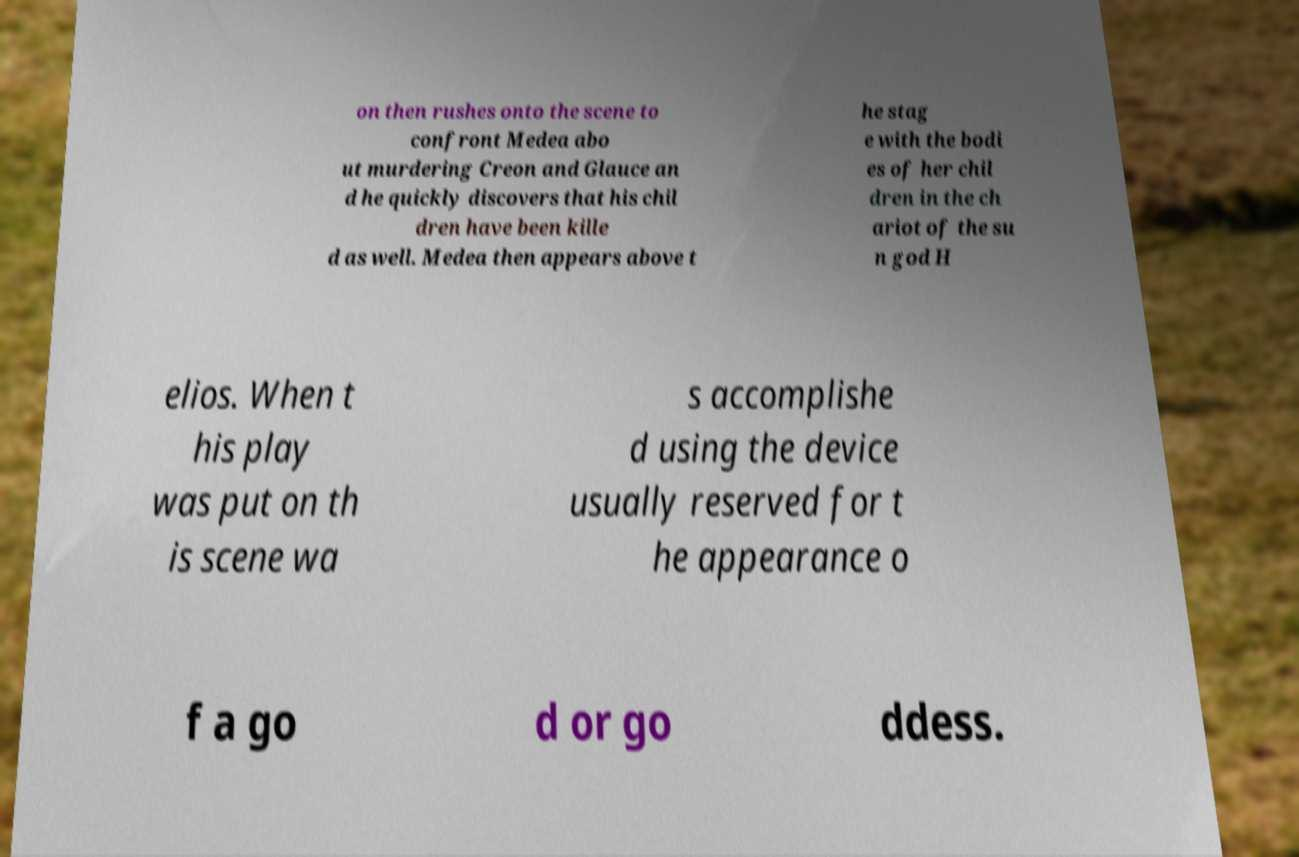Could you assist in decoding the text presented in this image and type it out clearly? on then rushes onto the scene to confront Medea abo ut murdering Creon and Glauce an d he quickly discovers that his chil dren have been kille d as well. Medea then appears above t he stag e with the bodi es of her chil dren in the ch ariot of the su n god H elios. When t his play was put on th is scene wa s accomplishe d using the device usually reserved for t he appearance o f a go d or go ddess. 